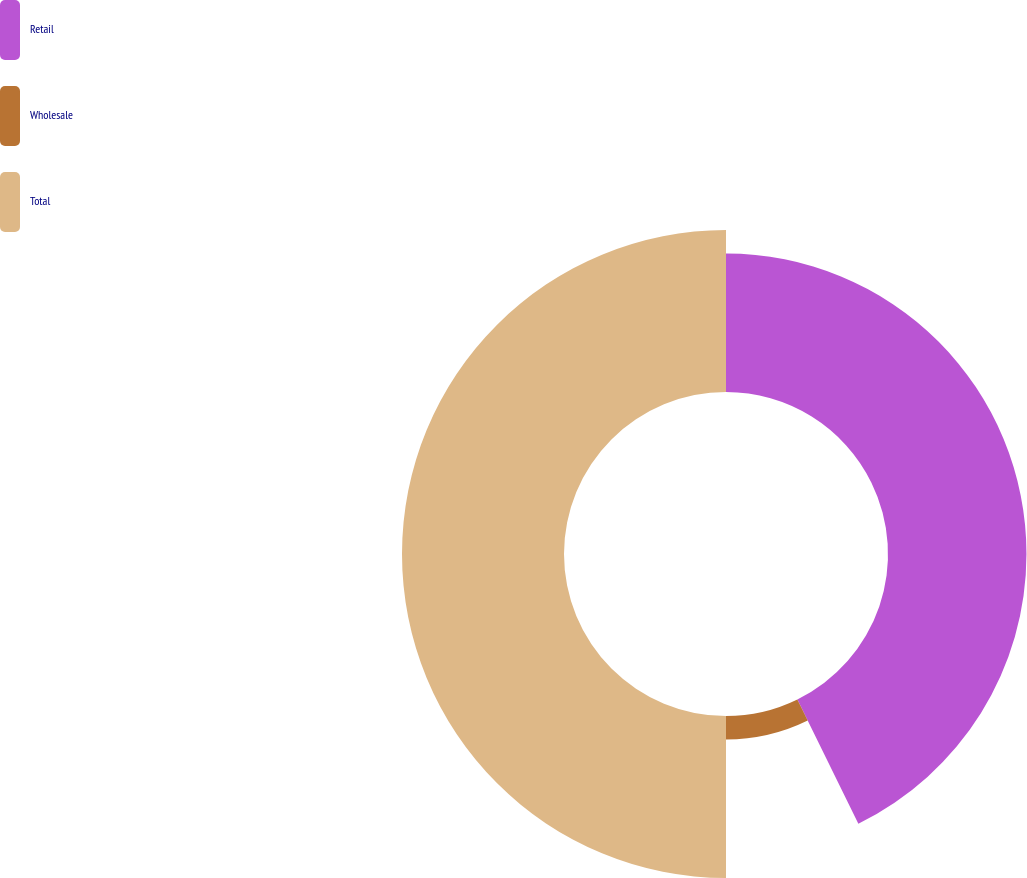<chart> <loc_0><loc_0><loc_500><loc_500><pie_chart><fcel>Retail<fcel>Wholesale<fcel>Total<nl><fcel>42.74%<fcel>7.26%<fcel>50.0%<nl></chart> 